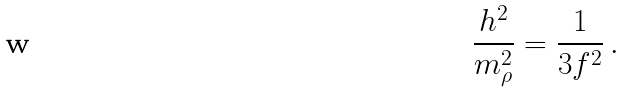<formula> <loc_0><loc_0><loc_500><loc_500>\frac { h ^ { 2 } } { m ^ { 2 } _ { \rho } } = \frac { 1 } { 3 f ^ { 2 } } \, .</formula> 